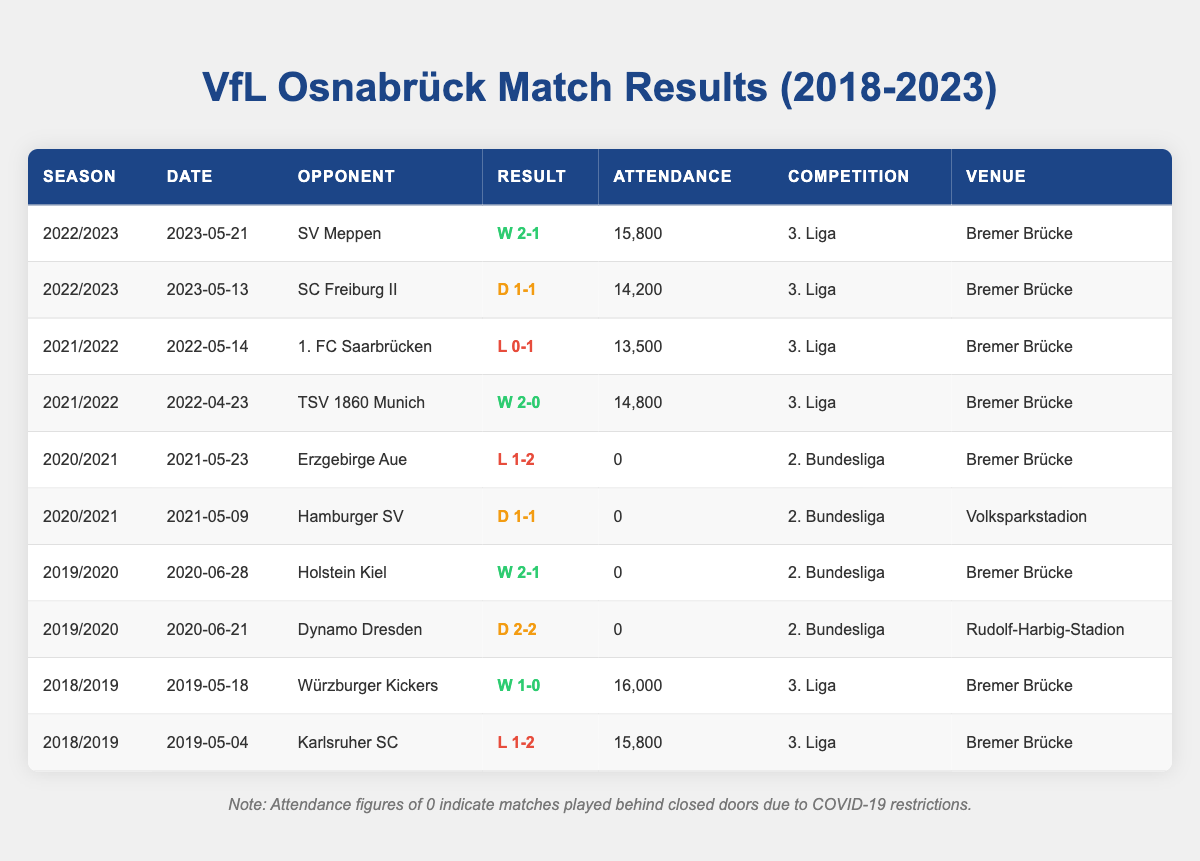What was the highest attendance recorded in a match for VfL Osnabrück? The attendance figures provided are 15,800 (in a match against SV Meppen on 2023-05-21) and 16,000 (in a match against Würzburger Kickers on 2019-05-18). Comparing these values, 16,000 is the highest attendance.
Answer: 16,000 How many matches did VfL Osnabrück win in the 2022/2023 season? In the 2022/2023 season, there are two matches listed: one against SV Meppen where they won (W 2-1), and one against SC Freiburg II which ended in a draw (D 1-1). Therefore, there is only one match won.
Answer: 1 Did VfL Osnabrück win more matches than they lost in the 2021/2022 season? In the 2021/2022 season, VfL Osnabrück won one match (against TSV 1860 Munich) and lost one match (against 1. FC Saarbrücken). Consequently, they did not win more matches than they lost, as the counts are equal at 1 win and 1 loss.
Answer: No What is the total attendance for all matches played at Bremer Brücke? The matches at Bremer Brücke with attendance figures are against SV Meppen (15,800), SC Freiburg II (14,200), 1. FC Saarbrücken (13,500), TSV 1860 Munich (14,800), and Würzburger Kickers (16,000). Summing these values gives 15,800 + 14,200 + 13,500 + 14,800 + 16,000 = 74,300.
Answer: 74,300 How many matches ended in a draw during the 2019/2020 season? In the 2019/2020 season, there are two results listed: one match against Dynamo Dresden that ended in a draw (D 2-2) and no other draw listed. Therefore, there was one match that ended in a draw for that season.
Answer: 1 What was the result of VfL Osnabrück's match against Karlsruher SC in the 2018/2019 season? Looking at the table for the 2018/2019 season, the match against Karlsruher SC is listed with the result "L 1-2", indicating that VfL Osnabrück lost this match.
Answer: L 1-2 In which season did VfL Osnabrück have zero attendance due to match restrictions? The matches with zero attendance were played during the 2020/2021 season against Erzgebirge Aue and Hamburger SV, indicating that both matches were behind closed doors due to COVID-19. Therefore, the season with zero attendance is 2020/2021.
Answer: 2020/2021 What was the average attendance of VfL Osnabrück's matches in the 2022/2023 season? The attendance figures for the 2022/2023 season are 15,800 for the match against SV Meppen and 14,200 for the match against SC Freiburg II. The average is calculated by summing the attendances (15,800 + 14,200 = 30,000) and dividing by the number of matches played (2). Thus, the average attendance is 30,000 / 2 = 15,000.
Answer: 15,000 